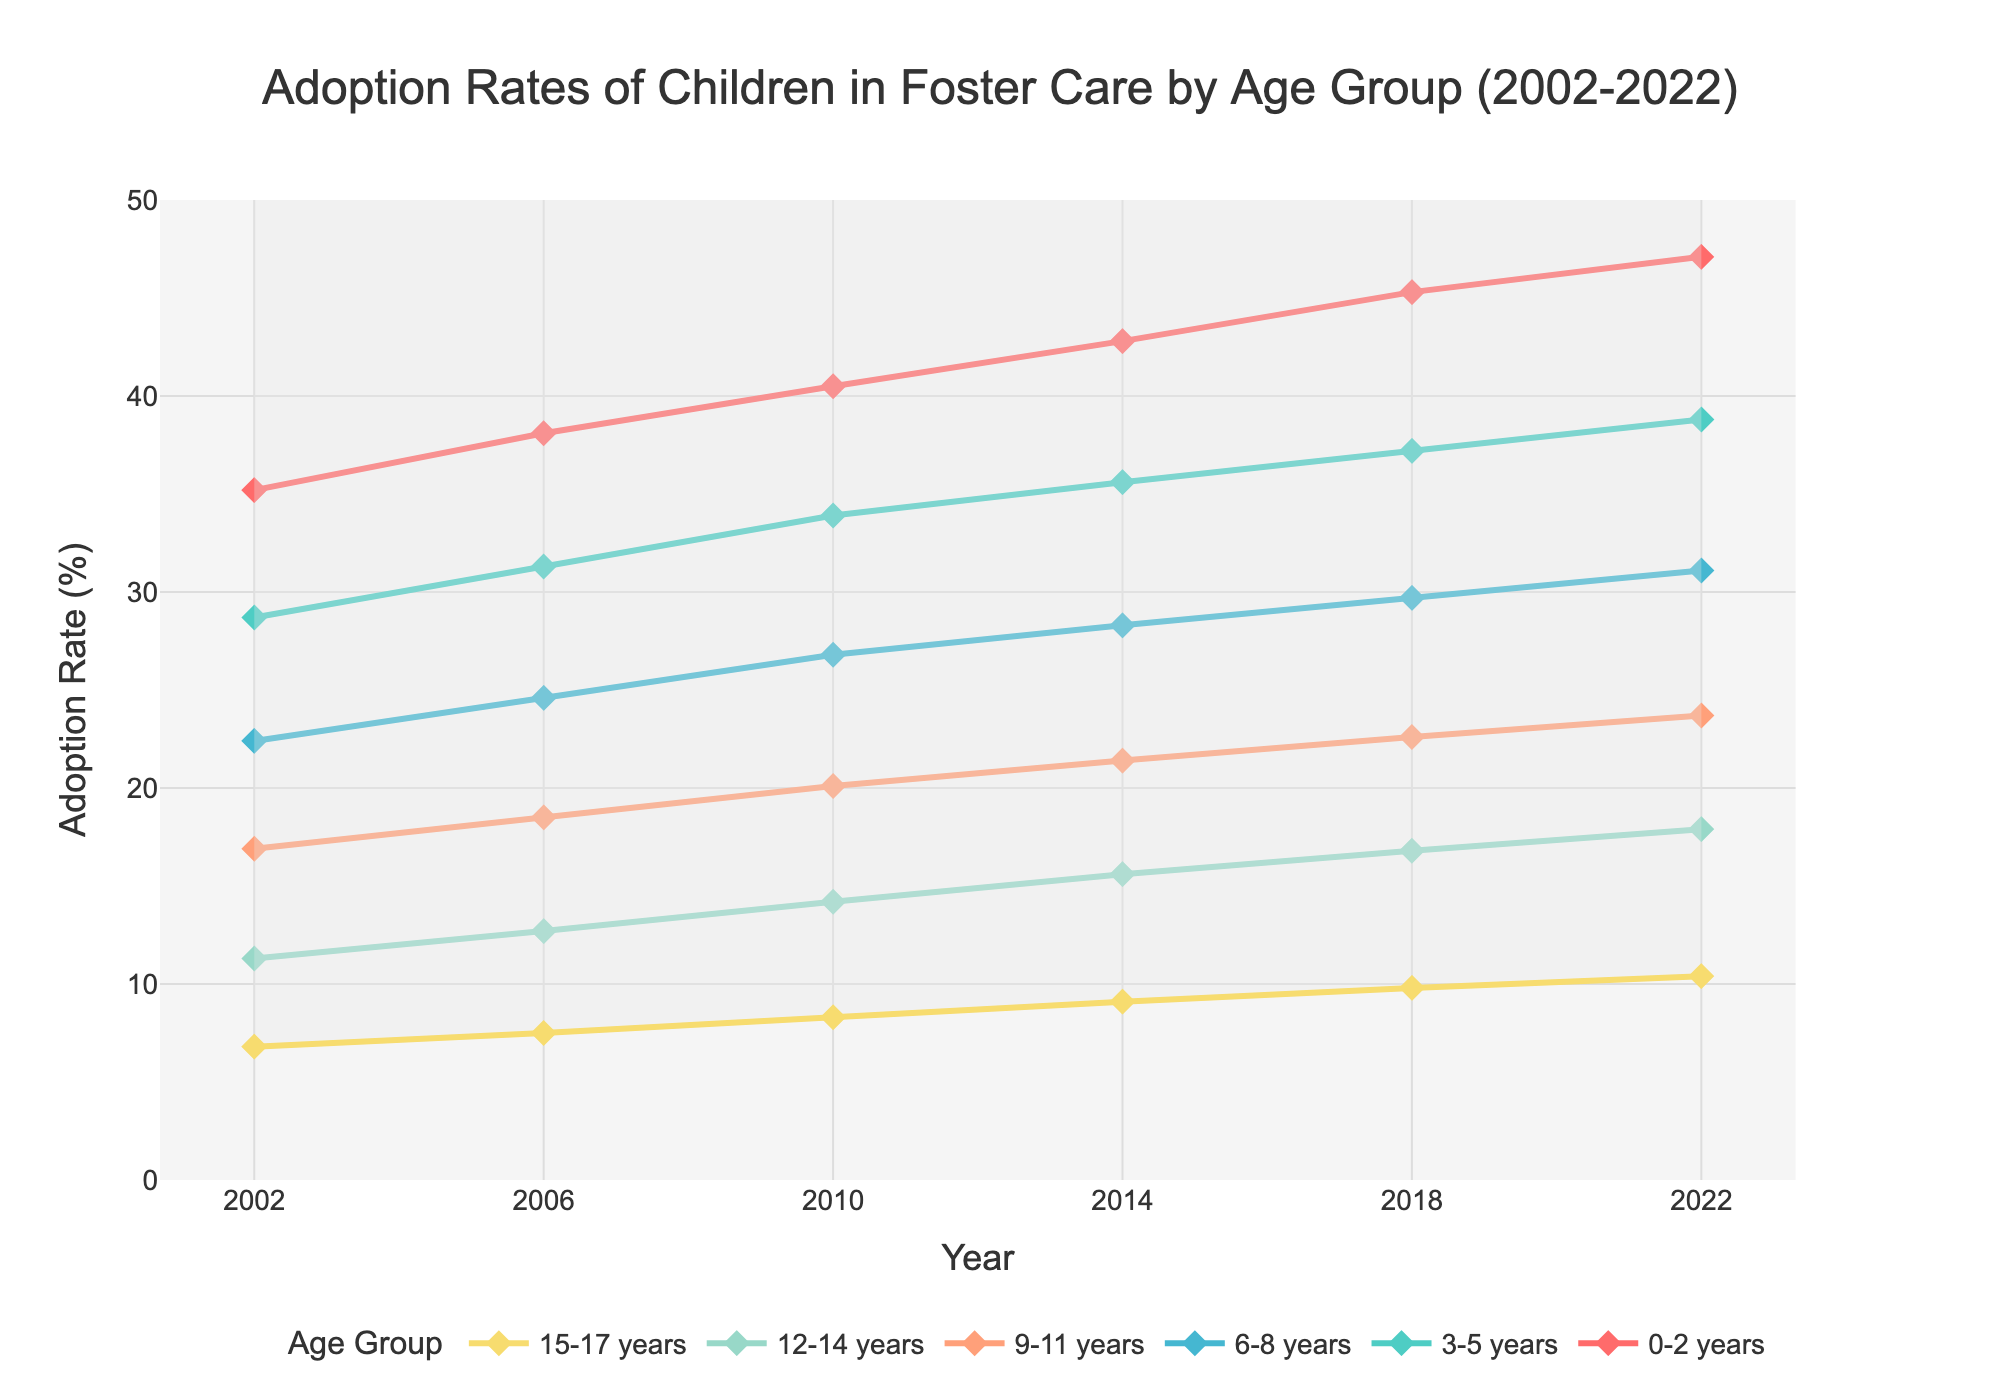What age group has the highest adoption rate in 2022? The line with the highest value in 2022 on the y-axis is for the 0-2 years age group.
Answer: 0-2 years Which age group shows the smallest increase in adoption rate from 2002 to 2022? The smallest increase is observed in the 15-17 years age group, rising from 6.8% in 2002 to 10.4% in 2022, an increase of 3.6%.
Answer: 15-17 years What is the average adoption rate for the 6-8 years age group over the 20-year period? Add the adoption rates for the years 2002, 2006, 2010, 2014, 2018, and 2022: 22.4 + 24.6 + 26.8 + 28.3 + 29.7 + 31.1 = 162.9. Divide by the number of years (6): 162.9 / 6 ≈ 27.15%.
Answer: 27.15% Which age group shows the greatest increase in adoption rates from 2002 to 2022? The greatest increase in adoption rates is seen in the 0-2 years age group, which increased from 35.2% in 2002 to 47.1% in 2022, an increase of 11.9%.
Answer: 0-2 years Between the 3-5 years and 9-11 years age groups, which had a higher adoption rate in 2014? In 2014, the adoption rate for the 3-5 years age group was 35.6%, while the 9-11 years age group was 21.4%. Therefore, the 3-5 years age group had a higher rate.
Answer: 3-5 years What is the difference in adoption rates between 0-2 years and 15-17 years age groups in 2002? Subtract the adoption rate of the 15-17 years group from the 0-2 years group in 2002: 35.2% - 6.8% = 28.4%.
Answer: 28.4% Which age group's adoption rate surpassed 30% first? The 0-2 years age group surpassed 30% first as it was above 30% already in 2002.
Answer: 0-2 years How does the trend of adoption rates for the 12-14 years age group compare to the 6-8 years age group over the 20 years? Both age groups show an increasing trend, but the 6-8 years age group consistently has a higher adoption rate than the 12-14 years age group throughout the 20-year period.
Answer: Increasing, higher In what year did the 3-5 years age group adoption rate first exceed 35%? The adoption rate of the 3-5 years age group exceeded 35% in 2014.
Answer: 2014 